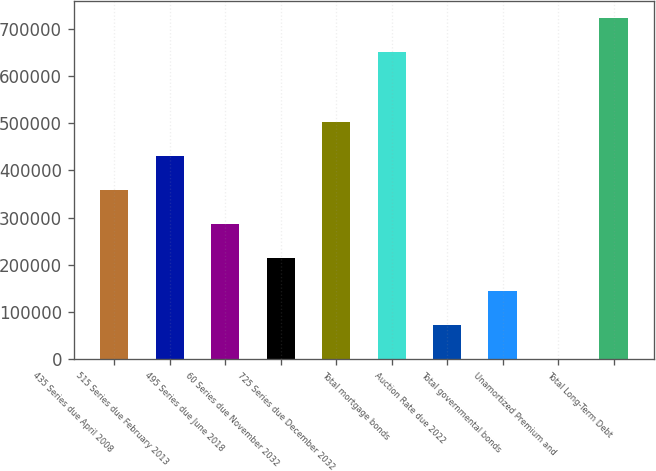Convert chart. <chart><loc_0><loc_0><loc_500><loc_500><bar_chart><fcel>435 Series due April 2008<fcel>515 Series due February 2013<fcel>495 Series due June 2018<fcel>60 Series due November 2032<fcel>725 Series due December 2032<fcel>Total mortgage bonds<fcel>Auction Rate due 2022<fcel>Total governmental bonds<fcel>Unamortized Premium and<fcel>Total Long-Term Debt<nl><fcel>358579<fcel>430103<fcel>287055<fcel>215530<fcel>501628<fcel>650000<fcel>72481.4<fcel>144006<fcel>957<fcel>721524<nl></chart> 